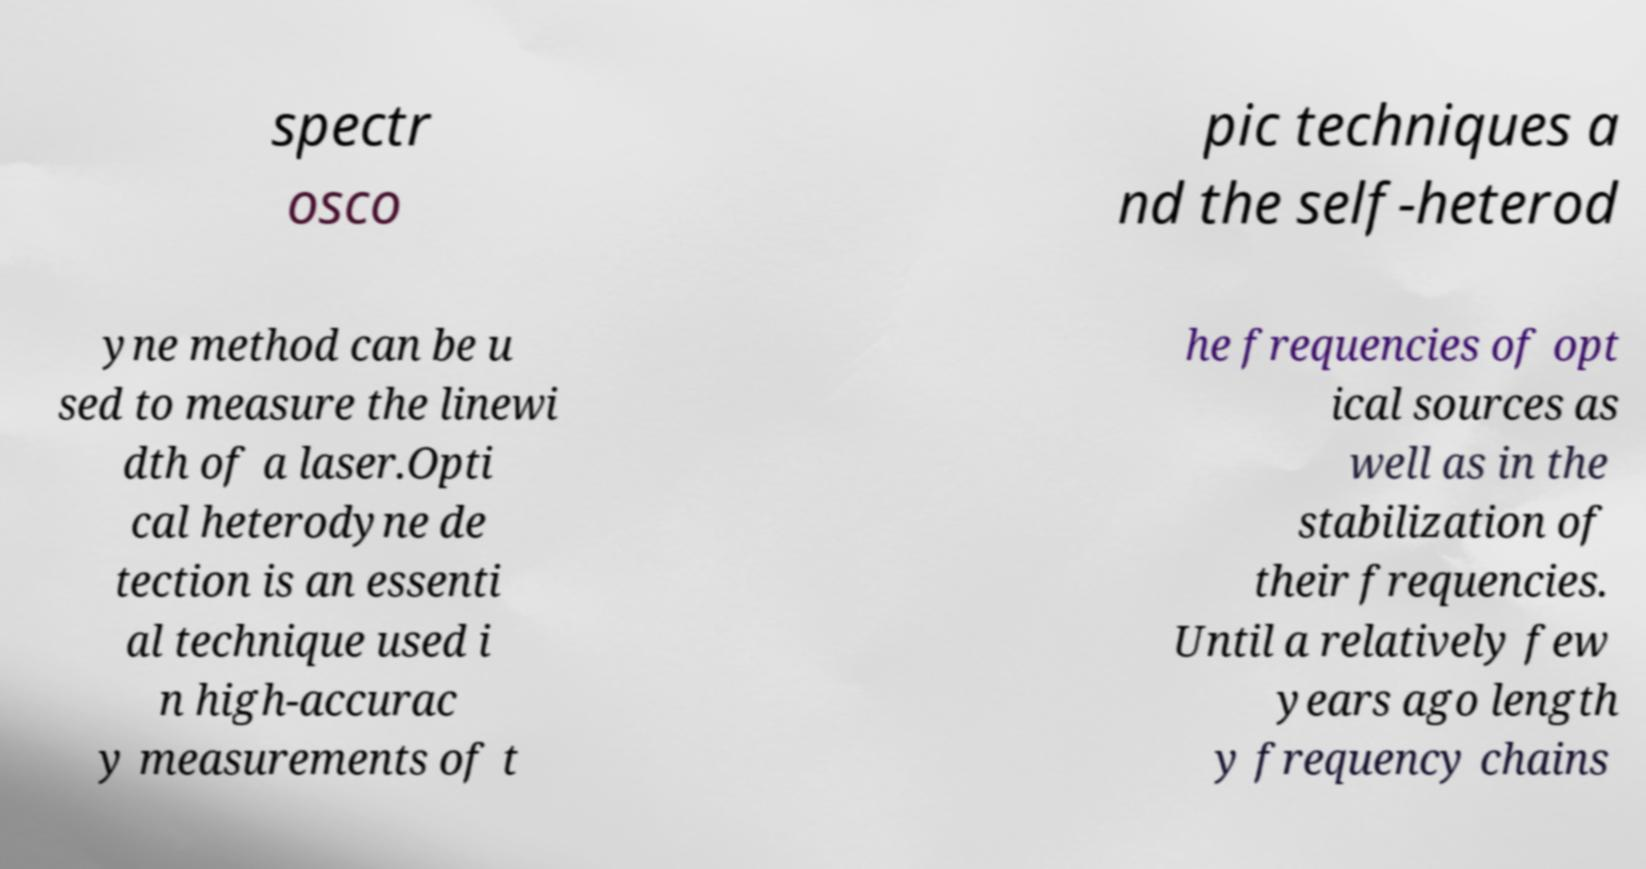Please read and relay the text visible in this image. What does it say? spectr osco pic techniques a nd the self-heterod yne method can be u sed to measure the linewi dth of a laser.Opti cal heterodyne de tection is an essenti al technique used i n high-accurac y measurements of t he frequencies of opt ical sources as well as in the stabilization of their frequencies. Until a relatively few years ago length y frequency chains 